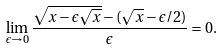<formula> <loc_0><loc_0><loc_500><loc_500>\lim _ { \epsilon \rightarrow 0 } \frac { \sqrt { x - \epsilon \sqrt { x } } - ( \sqrt { x } - \epsilon / 2 ) } { \epsilon } = 0 .</formula> 